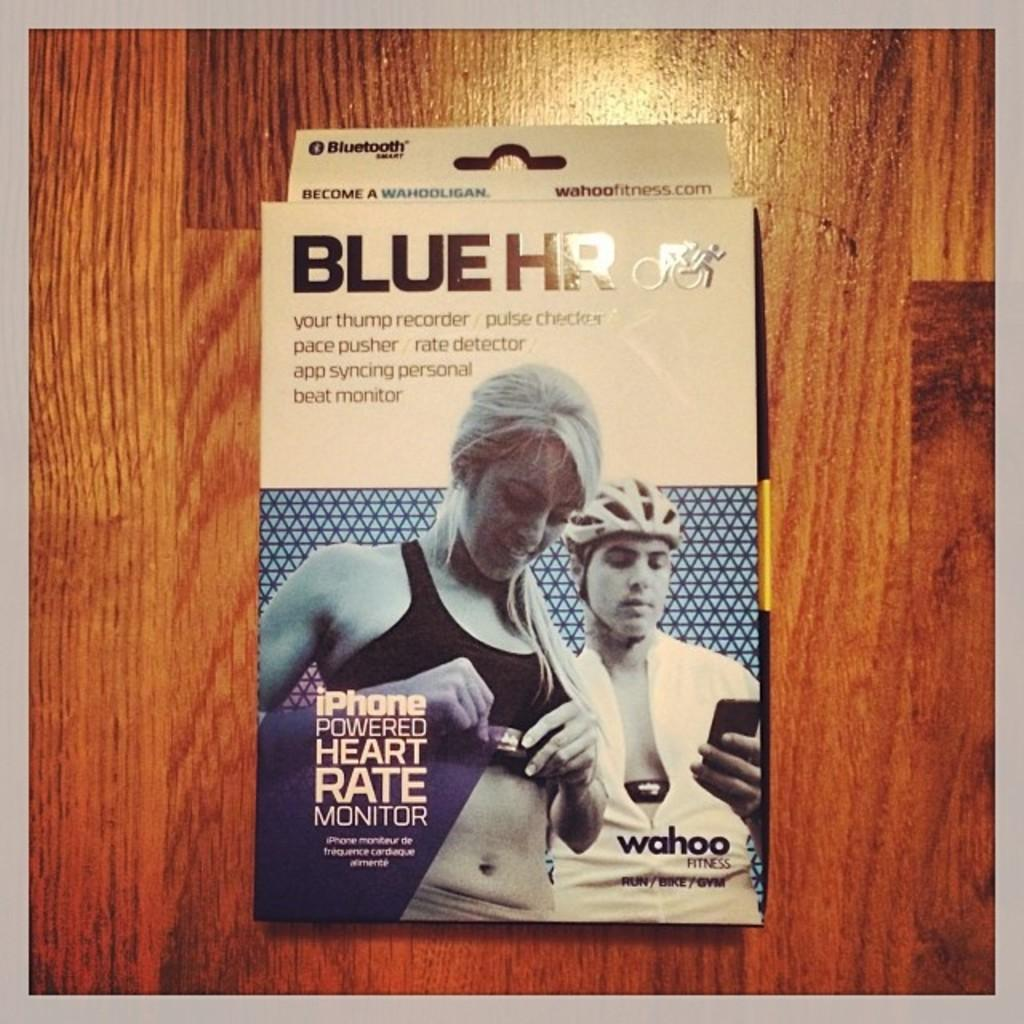<image>
Share a concise interpretation of the image provided. The name of this product is called "Blue HR." 